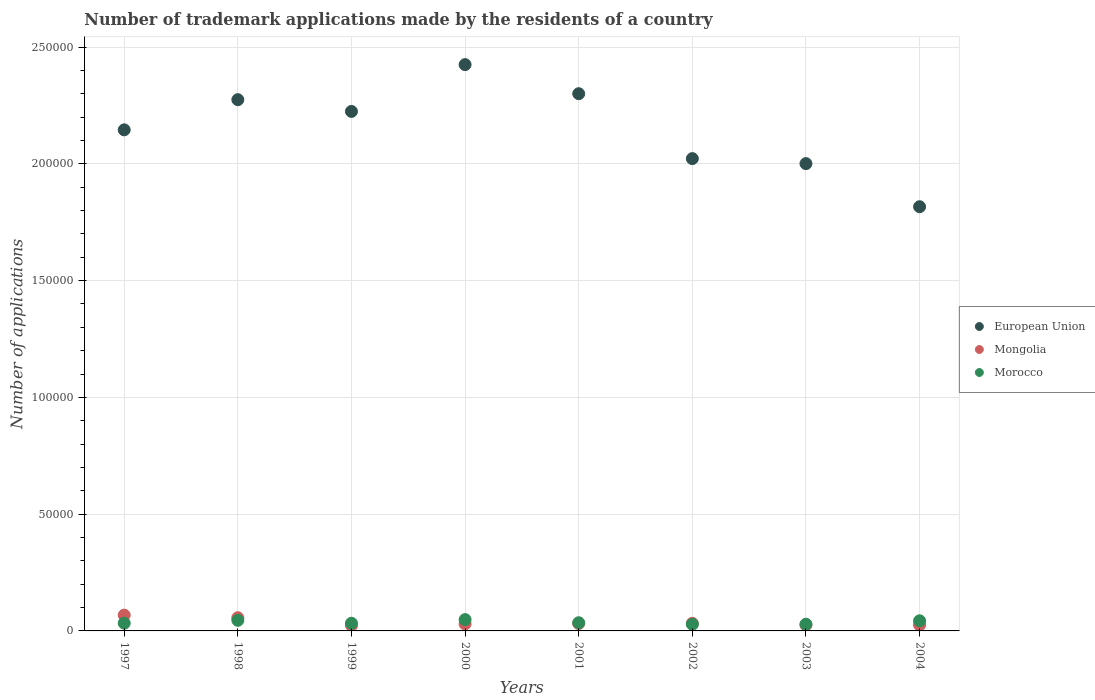How many different coloured dotlines are there?
Provide a short and direct response. 3. Is the number of dotlines equal to the number of legend labels?
Your response must be concise. Yes. What is the number of trademark applications made by the residents in Morocco in 2001?
Make the answer very short. 3499. Across all years, what is the maximum number of trademark applications made by the residents in Mongolia?
Offer a very short reply. 6760. Across all years, what is the minimum number of trademark applications made by the residents in Mongolia?
Your answer should be very brief. 2375. In which year was the number of trademark applications made by the residents in European Union maximum?
Your response must be concise. 2000. What is the total number of trademark applications made by the residents in European Union in the graph?
Make the answer very short. 1.72e+06. What is the difference between the number of trademark applications made by the residents in Morocco in 1998 and that in 2002?
Offer a terse response. 1691. What is the difference between the number of trademark applications made by the residents in Morocco in 1998 and the number of trademark applications made by the residents in Mongolia in 2003?
Provide a short and direct response. 2007. What is the average number of trademark applications made by the residents in Morocco per year?
Ensure brevity in your answer.  3691.5. In the year 1999, what is the difference between the number of trademark applications made by the residents in European Union and number of trademark applications made by the residents in Morocco?
Give a very brief answer. 2.19e+05. In how many years, is the number of trademark applications made by the residents in Mongolia greater than 200000?
Keep it short and to the point. 0. What is the ratio of the number of trademark applications made by the residents in Morocco in 2002 to that in 2003?
Your response must be concise. 0.99. Is the difference between the number of trademark applications made by the residents in European Union in 1998 and 2002 greater than the difference between the number of trademark applications made by the residents in Morocco in 1998 and 2002?
Provide a succinct answer. Yes. What is the difference between the highest and the second highest number of trademark applications made by the residents in European Union?
Provide a short and direct response. 1.25e+04. What is the difference between the highest and the lowest number of trademark applications made by the residents in Morocco?
Provide a short and direct response. 1990. In how many years, is the number of trademark applications made by the residents in European Union greater than the average number of trademark applications made by the residents in European Union taken over all years?
Provide a succinct answer. 4. Is the sum of the number of trademark applications made by the residents in Mongolia in 2000 and 2004 greater than the maximum number of trademark applications made by the residents in Morocco across all years?
Your response must be concise. Yes. Is the number of trademark applications made by the residents in Morocco strictly greater than the number of trademark applications made by the residents in European Union over the years?
Give a very brief answer. No. How many dotlines are there?
Give a very brief answer. 3. How many years are there in the graph?
Provide a succinct answer. 8. What is the difference between two consecutive major ticks on the Y-axis?
Your answer should be very brief. 5.00e+04. Does the graph contain grids?
Your answer should be compact. Yes. How are the legend labels stacked?
Your response must be concise. Vertical. What is the title of the graph?
Provide a short and direct response. Number of trademark applications made by the residents of a country. What is the label or title of the X-axis?
Provide a succinct answer. Years. What is the label or title of the Y-axis?
Your answer should be very brief. Number of applications. What is the Number of applications of European Union in 1997?
Make the answer very short. 2.15e+05. What is the Number of applications of Mongolia in 1997?
Provide a short and direct response. 6760. What is the Number of applications of Morocco in 1997?
Offer a terse response. 3312. What is the Number of applications of European Union in 1998?
Your answer should be very brief. 2.27e+05. What is the Number of applications of Mongolia in 1998?
Give a very brief answer. 5648. What is the Number of applications of Morocco in 1998?
Provide a succinct answer. 4540. What is the Number of applications in European Union in 1999?
Your answer should be compact. 2.22e+05. What is the Number of applications in Mongolia in 1999?
Offer a very short reply. 2375. What is the Number of applications in Morocco in 1999?
Your answer should be compact. 3283. What is the Number of applications in European Union in 2000?
Your answer should be very brief. 2.42e+05. What is the Number of applications of Mongolia in 2000?
Ensure brevity in your answer.  2970. What is the Number of applications of Morocco in 2000?
Provide a short and direct response. 4839. What is the Number of applications in European Union in 2001?
Your answer should be very brief. 2.30e+05. What is the Number of applications of Mongolia in 2001?
Offer a very short reply. 3189. What is the Number of applications of Morocco in 2001?
Your answer should be compact. 3499. What is the Number of applications in European Union in 2002?
Provide a short and direct response. 2.02e+05. What is the Number of applications of Mongolia in 2002?
Make the answer very short. 3260. What is the Number of applications of Morocco in 2002?
Give a very brief answer. 2849. What is the Number of applications in European Union in 2003?
Make the answer very short. 2.00e+05. What is the Number of applications of Mongolia in 2003?
Make the answer very short. 2533. What is the Number of applications in Morocco in 2003?
Give a very brief answer. 2875. What is the Number of applications of European Union in 2004?
Your response must be concise. 1.82e+05. What is the Number of applications of Mongolia in 2004?
Provide a succinct answer. 2559. What is the Number of applications in Morocco in 2004?
Offer a very short reply. 4335. Across all years, what is the maximum Number of applications of European Union?
Your response must be concise. 2.42e+05. Across all years, what is the maximum Number of applications of Mongolia?
Your answer should be compact. 6760. Across all years, what is the maximum Number of applications of Morocco?
Your response must be concise. 4839. Across all years, what is the minimum Number of applications in European Union?
Ensure brevity in your answer.  1.82e+05. Across all years, what is the minimum Number of applications in Mongolia?
Ensure brevity in your answer.  2375. Across all years, what is the minimum Number of applications in Morocco?
Your response must be concise. 2849. What is the total Number of applications of European Union in the graph?
Your answer should be compact. 1.72e+06. What is the total Number of applications in Mongolia in the graph?
Give a very brief answer. 2.93e+04. What is the total Number of applications in Morocco in the graph?
Offer a terse response. 2.95e+04. What is the difference between the Number of applications of European Union in 1997 and that in 1998?
Your response must be concise. -1.29e+04. What is the difference between the Number of applications in Mongolia in 1997 and that in 1998?
Give a very brief answer. 1112. What is the difference between the Number of applications in Morocco in 1997 and that in 1998?
Your answer should be very brief. -1228. What is the difference between the Number of applications of European Union in 1997 and that in 1999?
Provide a short and direct response. -7887. What is the difference between the Number of applications in Mongolia in 1997 and that in 1999?
Your response must be concise. 4385. What is the difference between the Number of applications in Morocco in 1997 and that in 1999?
Your response must be concise. 29. What is the difference between the Number of applications of European Union in 1997 and that in 2000?
Give a very brief answer. -2.79e+04. What is the difference between the Number of applications in Mongolia in 1997 and that in 2000?
Keep it short and to the point. 3790. What is the difference between the Number of applications in Morocco in 1997 and that in 2000?
Keep it short and to the point. -1527. What is the difference between the Number of applications in European Union in 1997 and that in 2001?
Your response must be concise. -1.55e+04. What is the difference between the Number of applications of Mongolia in 1997 and that in 2001?
Keep it short and to the point. 3571. What is the difference between the Number of applications of Morocco in 1997 and that in 2001?
Provide a succinct answer. -187. What is the difference between the Number of applications of European Union in 1997 and that in 2002?
Your answer should be very brief. 1.23e+04. What is the difference between the Number of applications of Mongolia in 1997 and that in 2002?
Offer a terse response. 3500. What is the difference between the Number of applications of Morocco in 1997 and that in 2002?
Your answer should be compact. 463. What is the difference between the Number of applications in European Union in 1997 and that in 2003?
Your response must be concise. 1.45e+04. What is the difference between the Number of applications of Mongolia in 1997 and that in 2003?
Your answer should be very brief. 4227. What is the difference between the Number of applications in Morocco in 1997 and that in 2003?
Offer a terse response. 437. What is the difference between the Number of applications in European Union in 1997 and that in 2004?
Your response must be concise. 3.29e+04. What is the difference between the Number of applications of Mongolia in 1997 and that in 2004?
Your response must be concise. 4201. What is the difference between the Number of applications in Morocco in 1997 and that in 2004?
Provide a succinct answer. -1023. What is the difference between the Number of applications in European Union in 1998 and that in 1999?
Make the answer very short. 5029. What is the difference between the Number of applications in Mongolia in 1998 and that in 1999?
Provide a short and direct response. 3273. What is the difference between the Number of applications in Morocco in 1998 and that in 1999?
Your answer should be very brief. 1257. What is the difference between the Number of applications of European Union in 1998 and that in 2000?
Make the answer very short. -1.50e+04. What is the difference between the Number of applications of Mongolia in 1998 and that in 2000?
Provide a short and direct response. 2678. What is the difference between the Number of applications in Morocco in 1998 and that in 2000?
Ensure brevity in your answer.  -299. What is the difference between the Number of applications of European Union in 1998 and that in 2001?
Keep it short and to the point. -2562. What is the difference between the Number of applications in Mongolia in 1998 and that in 2001?
Make the answer very short. 2459. What is the difference between the Number of applications of Morocco in 1998 and that in 2001?
Offer a terse response. 1041. What is the difference between the Number of applications in European Union in 1998 and that in 2002?
Your answer should be very brief. 2.52e+04. What is the difference between the Number of applications of Mongolia in 1998 and that in 2002?
Offer a terse response. 2388. What is the difference between the Number of applications of Morocco in 1998 and that in 2002?
Your answer should be compact. 1691. What is the difference between the Number of applications in European Union in 1998 and that in 2003?
Give a very brief answer. 2.74e+04. What is the difference between the Number of applications in Mongolia in 1998 and that in 2003?
Provide a short and direct response. 3115. What is the difference between the Number of applications in Morocco in 1998 and that in 2003?
Your answer should be very brief. 1665. What is the difference between the Number of applications of European Union in 1998 and that in 2004?
Your response must be concise. 4.58e+04. What is the difference between the Number of applications of Mongolia in 1998 and that in 2004?
Your response must be concise. 3089. What is the difference between the Number of applications of Morocco in 1998 and that in 2004?
Offer a terse response. 205. What is the difference between the Number of applications in European Union in 1999 and that in 2000?
Keep it short and to the point. -2.00e+04. What is the difference between the Number of applications in Mongolia in 1999 and that in 2000?
Your answer should be very brief. -595. What is the difference between the Number of applications in Morocco in 1999 and that in 2000?
Offer a terse response. -1556. What is the difference between the Number of applications in European Union in 1999 and that in 2001?
Your answer should be very brief. -7591. What is the difference between the Number of applications in Mongolia in 1999 and that in 2001?
Give a very brief answer. -814. What is the difference between the Number of applications of Morocco in 1999 and that in 2001?
Keep it short and to the point. -216. What is the difference between the Number of applications in European Union in 1999 and that in 2002?
Your answer should be compact. 2.02e+04. What is the difference between the Number of applications of Mongolia in 1999 and that in 2002?
Give a very brief answer. -885. What is the difference between the Number of applications in Morocco in 1999 and that in 2002?
Keep it short and to the point. 434. What is the difference between the Number of applications in European Union in 1999 and that in 2003?
Offer a very short reply. 2.24e+04. What is the difference between the Number of applications in Mongolia in 1999 and that in 2003?
Give a very brief answer. -158. What is the difference between the Number of applications of Morocco in 1999 and that in 2003?
Provide a succinct answer. 408. What is the difference between the Number of applications in European Union in 1999 and that in 2004?
Keep it short and to the point. 4.08e+04. What is the difference between the Number of applications of Mongolia in 1999 and that in 2004?
Ensure brevity in your answer.  -184. What is the difference between the Number of applications in Morocco in 1999 and that in 2004?
Your response must be concise. -1052. What is the difference between the Number of applications in European Union in 2000 and that in 2001?
Give a very brief answer. 1.25e+04. What is the difference between the Number of applications in Mongolia in 2000 and that in 2001?
Ensure brevity in your answer.  -219. What is the difference between the Number of applications of Morocco in 2000 and that in 2001?
Give a very brief answer. 1340. What is the difference between the Number of applications in European Union in 2000 and that in 2002?
Offer a terse response. 4.03e+04. What is the difference between the Number of applications in Mongolia in 2000 and that in 2002?
Your response must be concise. -290. What is the difference between the Number of applications in Morocco in 2000 and that in 2002?
Keep it short and to the point. 1990. What is the difference between the Number of applications of European Union in 2000 and that in 2003?
Give a very brief answer. 4.24e+04. What is the difference between the Number of applications of Mongolia in 2000 and that in 2003?
Keep it short and to the point. 437. What is the difference between the Number of applications of Morocco in 2000 and that in 2003?
Your answer should be compact. 1964. What is the difference between the Number of applications in European Union in 2000 and that in 2004?
Your answer should be compact. 6.08e+04. What is the difference between the Number of applications in Mongolia in 2000 and that in 2004?
Make the answer very short. 411. What is the difference between the Number of applications in Morocco in 2000 and that in 2004?
Offer a very short reply. 504. What is the difference between the Number of applications of European Union in 2001 and that in 2002?
Provide a short and direct response. 2.78e+04. What is the difference between the Number of applications of Mongolia in 2001 and that in 2002?
Your response must be concise. -71. What is the difference between the Number of applications in Morocco in 2001 and that in 2002?
Give a very brief answer. 650. What is the difference between the Number of applications in European Union in 2001 and that in 2003?
Ensure brevity in your answer.  2.99e+04. What is the difference between the Number of applications in Mongolia in 2001 and that in 2003?
Your answer should be compact. 656. What is the difference between the Number of applications in Morocco in 2001 and that in 2003?
Offer a terse response. 624. What is the difference between the Number of applications of European Union in 2001 and that in 2004?
Give a very brief answer. 4.84e+04. What is the difference between the Number of applications of Mongolia in 2001 and that in 2004?
Your response must be concise. 630. What is the difference between the Number of applications in Morocco in 2001 and that in 2004?
Make the answer very short. -836. What is the difference between the Number of applications of European Union in 2002 and that in 2003?
Offer a very short reply. 2142. What is the difference between the Number of applications of Mongolia in 2002 and that in 2003?
Your response must be concise. 727. What is the difference between the Number of applications of Morocco in 2002 and that in 2003?
Give a very brief answer. -26. What is the difference between the Number of applications of European Union in 2002 and that in 2004?
Ensure brevity in your answer.  2.06e+04. What is the difference between the Number of applications of Mongolia in 2002 and that in 2004?
Give a very brief answer. 701. What is the difference between the Number of applications of Morocco in 2002 and that in 2004?
Provide a short and direct response. -1486. What is the difference between the Number of applications in European Union in 2003 and that in 2004?
Keep it short and to the point. 1.85e+04. What is the difference between the Number of applications of Morocco in 2003 and that in 2004?
Give a very brief answer. -1460. What is the difference between the Number of applications of European Union in 1997 and the Number of applications of Mongolia in 1998?
Keep it short and to the point. 2.09e+05. What is the difference between the Number of applications in European Union in 1997 and the Number of applications in Morocco in 1998?
Offer a very short reply. 2.10e+05. What is the difference between the Number of applications of Mongolia in 1997 and the Number of applications of Morocco in 1998?
Keep it short and to the point. 2220. What is the difference between the Number of applications in European Union in 1997 and the Number of applications in Mongolia in 1999?
Give a very brief answer. 2.12e+05. What is the difference between the Number of applications of European Union in 1997 and the Number of applications of Morocco in 1999?
Provide a succinct answer. 2.11e+05. What is the difference between the Number of applications in Mongolia in 1997 and the Number of applications in Morocco in 1999?
Keep it short and to the point. 3477. What is the difference between the Number of applications of European Union in 1997 and the Number of applications of Mongolia in 2000?
Keep it short and to the point. 2.12e+05. What is the difference between the Number of applications of European Union in 1997 and the Number of applications of Morocco in 2000?
Your response must be concise. 2.10e+05. What is the difference between the Number of applications of Mongolia in 1997 and the Number of applications of Morocco in 2000?
Offer a very short reply. 1921. What is the difference between the Number of applications of European Union in 1997 and the Number of applications of Mongolia in 2001?
Your answer should be very brief. 2.11e+05. What is the difference between the Number of applications in European Union in 1997 and the Number of applications in Morocco in 2001?
Your response must be concise. 2.11e+05. What is the difference between the Number of applications of Mongolia in 1997 and the Number of applications of Morocco in 2001?
Provide a succinct answer. 3261. What is the difference between the Number of applications of European Union in 1997 and the Number of applications of Mongolia in 2002?
Give a very brief answer. 2.11e+05. What is the difference between the Number of applications of European Union in 1997 and the Number of applications of Morocco in 2002?
Make the answer very short. 2.12e+05. What is the difference between the Number of applications of Mongolia in 1997 and the Number of applications of Morocco in 2002?
Your answer should be compact. 3911. What is the difference between the Number of applications of European Union in 1997 and the Number of applications of Mongolia in 2003?
Provide a succinct answer. 2.12e+05. What is the difference between the Number of applications in European Union in 1997 and the Number of applications in Morocco in 2003?
Your answer should be compact. 2.12e+05. What is the difference between the Number of applications in Mongolia in 1997 and the Number of applications in Morocco in 2003?
Provide a short and direct response. 3885. What is the difference between the Number of applications in European Union in 1997 and the Number of applications in Mongolia in 2004?
Offer a very short reply. 2.12e+05. What is the difference between the Number of applications in European Union in 1997 and the Number of applications in Morocco in 2004?
Your response must be concise. 2.10e+05. What is the difference between the Number of applications of Mongolia in 1997 and the Number of applications of Morocco in 2004?
Provide a short and direct response. 2425. What is the difference between the Number of applications of European Union in 1998 and the Number of applications of Mongolia in 1999?
Provide a short and direct response. 2.25e+05. What is the difference between the Number of applications of European Union in 1998 and the Number of applications of Morocco in 1999?
Your answer should be compact. 2.24e+05. What is the difference between the Number of applications of Mongolia in 1998 and the Number of applications of Morocco in 1999?
Provide a succinct answer. 2365. What is the difference between the Number of applications of European Union in 1998 and the Number of applications of Mongolia in 2000?
Give a very brief answer. 2.24e+05. What is the difference between the Number of applications of European Union in 1998 and the Number of applications of Morocco in 2000?
Offer a terse response. 2.23e+05. What is the difference between the Number of applications of Mongolia in 1998 and the Number of applications of Morocco in 2000?
Keep it short and to the point. 809. What is the difference between the Number of applications in European Union in 1998 and the Number of applications in Mongolia in 2001?
Provide a succinct answer. 2.24e+05. What is the difference between the Number of applications in European Union in 1998 and the Number of applications in Morocco in 2001?
Your answer should be very brief. 2.24e+05. What is the difference between the Number of applications in Mongolia in 1998 and the Number of applications in Morocco in 2001?
Offer a terse response. 2149. What is the difference between the Number of applications of European Union in 1998 and the Number of applications of Mongolia in 2002?
Your answer should be very brief. 2.24e+05. What is the difference between the Number of applications in European Union in 1998 and the Number of applications in Morocco in 2002?
Offer a terse response. 2.25e+05. What is the difference between the Number of applications in Mongolia in 1998 and the Number of applications in Morocco in 2002?
Your answer should be compact. 2799. What is the difference between the Number of applications in European Union in 1998 and the Number of applications in Mongolia in 2003?
Your answer should be very brief. 2.25e+05. What is the difference between the Number of applications in European Union in 1998 and the Number of applications in Morocco in 2003?
Offer a terse response. 2.25e+05. What is the difference between the Number of applications of Mongolia in 1998 and the Number of applications of Morocco in 2003?
Your response must be concise. 2773. What is the difference between the Number of applications of European Union in 1998 and the Number of applications of Mongolia in 2004?
Make the answer very short. 2.25e+05. What is the difference between the Number of applications in European Union in 1998 and the Number of applications in Morocco in 2004?
Your answer should be compact. 2.23e+05. What is the difference between the Number of applications in Mongolia in 1998 and the Number of applications in Morocco in 2004?
Offer a very short reply. 1313. What is the difference between the Number of applications in European Union in 1999 and the Number of applications in Mongolia in 2000?
Your answer should be compact. 2.19e+05. What is the difference between the Number of applications of European Union in 1999 and the Number of applications of Morocco in 2000?
Offer a terse response. 2.18e+05. What is the difference between the Number of applications of Mongolia in 1999 and the Number of applications of Morocco in 2000?
Offer a very short reply. -2464. What is the difference between the Number of applications in European Union in 1999 and the Number of applications in Mongolia in 2001?
Offer a very short reply. 2.19e+05. What is the difference between the Number of applications of European Union in 1999 and the Number of applications of Morocco in 2001?
Offer a terse response. 2.19e+05. What is the difference between the Number of applications in Mongolia in 1999 and the Number of applications in Morocco in 2001?
Your answer should be very brief. -1124. What is the difference between the Number of applications of European Union in 1999 and the Number of applications of Mongolia in 2002?
Provide a succinct answer. 2.19e+05. What is the difference between the Number of applications of European Union in 1999 and the Number of applications of Morocco in 2002?
Keep it short and to the point. 2.20e+05. What is the difference between the Number of applications of Mongolia in 1999 and the Number of applications of Morocco in 2002?
Offer a terse response. -474. What is the difference between the Number of applications in European Union in 1999 and the Number of applications in Mongolia in 2003?
Provide a succinct answer. 2.20e+05. What is the difference between the Number of applications of European Union in 1999 and the Number of applications of Morocco in 2003?
Your answer should be very brief. 2.20e+05. What is the difference between the Number of applications of Mongolia in 1999 and the Number of applications of Morocco in 2003?
Your response must be concise. -500. What is the difference between the Number of applications in European Union in 1999 and the Number of applications in Mongolia in 2004?
Provide a short and direct response. 2.20e+05. What is the difference between the Number of applications of European Union in 1999 and the Number of applications of Morocco in 2004?
Offer a terse response. 2.18e+05. What is the difference between the Number of applications of Mongolia in 1999 and the Number of applications of Morocco in 2004?
Give a very brief answer. -1960. What is the difference between the Number of applications of European Union in 2000 and the Number of applications of Mongolia in 2001?
Offer a terse response. 2.39e+05. What is the difference between the Number of applications in European Union in 2000 and the Number of applications in Morocco in 2001?
Keep it short and to the point. 2.39e+05. What is the difference between the Number of applications of Mongolia in 2000 and the Number of applications of Morocco in 2001?
Your answer should be very brief. -529. What is the difference between the Number of applications of European Union in 2000 and the Number of applications of Mongolia in 2002?
Provide a short and direct response. 2.39e+05. What is the difference between the Number of applications of European Union in 2000 and the Number of applications of Morocco in 2002?
Your response must be concise. 2.40e+05. What is the difference between the Number of applications in Mongolia in 2000 and the Number of applications in Morocco in 2002?
Your answer should be compact. 121. What is the difference between the Number of applications of European Union in 2000 and the Number of applications of Mongolia in 2003?
Provide a succinct answer. 2.40e+05. What is the difference between the Number of applications in European Union in 2000 and the Number of applications in Morocco in 2003?
Make the answer very short. 2.40e+05. What is the difference between the Number of applications in Mongolia in 2000 and the Number of applications in Morocco in 2003?
Your response must be concise. 95. What is the difference between the Number of applications of European Union in 2000 and the Number of applications of Mongolia in 2004?
Offer a terse response. 2.40e+05. What is the difference between the Number of applications of European Union in 2000 and the Number of applications of Morocco in 2004?
Offer a terse response. 2.38e+05. What is the difference between the Number of applications in Mongolia in 2000 and the Number of applications in Morocco in 2004?
Your response must be concise. -1365. What is the difference between the Number of applications of European Union in 2001 and the Number of applications of Mongolia in 2002?
Provide a short and direct response. 2.27e+05. What is the difference between the Number of applications of European Union in 2001 and the Number of applications of Morocco in 2002?
Offer a terse response. 2.27e+05. What is the difference between the Number of applications of Mongolia in 2001 and the Number of applications of Morocco in 2002?
Ensure brevity in your answer.  340. What is the difference between the Number of applications in European Union in 2001 and the Number of applications in Mongolia in 2003?
Keep it short and to the point. 2.27e+05. What is the difference between the Number of applications in European Union in 2001 and the Number of applications in Morocco in 2003?
Your answer should be very brief. 2.27e+05. What is the difference between the Number of applications in Mongolia in 2001 and the Number of applications in Morocco in 2003?
Your answer should be compact. 314. What is the difference between the Number of applications in European Union in 2001 and the Number of applications in Mongolia in 2004?
Your response must be concise. 2.27e+05. What is the difference between the Number of applications of European Union in 2001 and the Number of applications of Morocco in 2004?
Offer a terse response. 2.26e+05. What is the difference between the Number of applications in Mongolia in 2001 and the Number of applications in Morocco in 2004?
Offer a terse response. -1146. What is the difference between the Number of applications of European Union in 2002 and the Number of applications of Mongolia in 2003?
Ensure brevity in your answer.  2.00e+05. What is the difference between the Number of applications in European Union in 2002 and the Number of applications in Morocco in 2003?
Provide a short and direct response. 1.99e+05. What is the difference between the Number of applications of Mongolia in 2002 and the Number of applications of Morocco in 2003?
Provide a succinct answer. 385. What is the difference between the Number of applications in European Union in 2002 and the Number of applications in Mongolia in 2004?
Your response must be concise. 2.00e+05. What is the difference between the Number of applications in European Union in 2002 and the Number of applications in Morocco in 2004?
Provide a succinct answer. 1.98e+05. What is the difference between the Number of applications in Mongolia in 2002 and the Number of applications in Morocco in 2004?
Make the answer very short. -1075. What is the difference between the Number of applications in European Union in 2003 and the Number of applications in Mongolia in 2004?
Provide a succinct answer. 1.98e+05. What is the difference between the Number of applications in European Union in 2003 and the Number of applications in Morocco in 2004?
Ensure brevity in your answer.  1.96e+05. What is the difference between the Number of applications in Mongolia in 2003 and the Number of applications in Morocco in 2004?
Give a very brief answer. -1802. What is the average Number of applications in European Union per year?
Ensure brevity in your answer.  2.15e+05. What is the average Number of applications of Mongolia per year?
Your answer should be very brief. 3661.75. What is the average Number of applications in Morocco per year?
Your answer should be compact. 3691.5. In the year 1997, what is the difference between the Number of applications in European Union and Number of applications in Mongolia?
Give a very brief answer. 2.08e+05. In the year 1997, what is the difference between the Number of applications of European Union and Number of applications of Morocco?
Give a very brief answer. 2.11e+05. In the year 1997, what is the difference between the Number of applications in Mongolia and Number of applications in Morocco?
Your response must be concise. 3448. In the year 1998, what is the difference between the Number of applications in European Union and Number of applications in Mongolia?
Keep it short and to the point. 2.22e+05. In the year 1998, what is the difference between the Number of applications of European Union and Number of applications of Morocco?
Your answer should be compact. 2.23e+05. In the year 1998, what is the difference between the Number of applications in Mongolia and Number of applications in Morocco?
Make the answer very short. 1108. In the year 1999, what is the difference between the Number of applications of European Union and Number of applications of Mongolia?
Keep it short and to the point. 2.20e+05. In the year 1999, what is the difference between the Number of applications in European Union and Number of applications in Morocco?
Provide a succinct answer. 2.19e+05. In the year 1999, what is the difference between the Number of applications in Mongolia and Number of applications in Morocco?
Your answer should be very brief. -908. In the year 2000, what is the difference between the Number of applications in European Union and Number of applications in Mongolia?
Your response must be concise. 2.40e+05. In the year 2000, what is the difference between the Number of applications of European Union and Number of applications of Morocco?
Your answer should be compact. 2.38e+05. In the year 2000, what is the difference between the Number of applications in Mongolia and Number of applications in Morocco?
Offer a terse response. -1869. In the year 2001, what is the difference between the Number of applications in European Union and Number of applications in Mongolia?
Your answer should be compact. 2.27e+05. In the year 2001, what is the difference between the Number of applications of European Union and Number of applications of Morocco?
Give a very brief answer. 2.27e+05. In the year 2001, what is the difference between the Number of applications of Mongolia and Number of applications of Morocco?
Your answer should be very brief. -310. In the year 2002, what is the difference between the Number of applications in European Union and Number of applications in Mongolia?
Provide a short and direct response. 1.99e+05. In the year 2002, what is the difference between the Number of applications in European Union and Number of applications in Morocco?
Your answer should be very brief. 1.99e+05. In the year 2002, what is the difference between the Number of applications in Mongolia and Number of applications in Morocco?
Provide a short and direct response. 411. In the year 2003, what is the difference between the Number of applications in European Union and Number of applications in Mongolia?
Make the answer very short. 1.98e+05. In the year 2003, what is the difference between the Number of applications in European Union and Number of applications in Morocco?
Keep it short and to the point. 1.97e+05. In the year 2003, what is the difference between the Number of applications in Mongolia and Number of applications in Morocco?
Your response must be concise. -342. In the year 2004, what is the difference between the Number of applications in European Union and Number of applications in Mongolia?
Your answer should be very brief. 1.79e+05. In the year 2004, what is the difference between the Number of applications in European Union and Number of applications in Morocco?
Give a very brief answer. 1.77e+05. In the year 2004, what is the difference between the Number of applications of Mongolia and Number of applications of Morocco?
Provide a succinct answer. -1776. What is the ratio of the Number of applications of European Union in 1997 to that in 1998?
Provide a short and direct response. 0.94. What is the ratio of the Number of applications in Mongolia in 1997 to that in 1998?
Your response must be concise. 1.2. What is the ratio of the Number of applications of Morocco in 1997 to that in 1998?
Give a very brief answer. 0.73. What is the ratio of the Number of applications in European Union in 1997 to that in 1999?
Offer a very short reply. 0.96. What is the ratio of the Number of applications of Mongolia in 1997 to that in 1999?
Provide a succinct answer. 2.85. What is the ratio of the Number of applications of Morocco in 1997 to that in 1999?
Give a very brief answer. 1.01. What is the ratio of the Number of applications of European Union in 1997 to that in 2000?
Offer a terse response. 0.88. What is the ratio of the Number of applications of Mongolia in 1997 to that in 2000?
Make the answer very short. 2.28. What is the ratio of the Number of applications in Morocco in 1997 to that in 2000?
Make the answer very short. 0.68. What is the ratio of the Number of applications in European Union in 1997 to that in 2001?
Provide a succinct answer. 0.93. What is the ratio of the Number of applications of Mongolia in 1997 to that in 2001?
Make the answer very short. 2.12. What is the ratio of the Number of applications in Morocco in 1997 to that in 2001?
Ensure brevity in your answer.  0.95. What is the ratio of the Number of applications in European Union in 1997 to that in 2002?
Keep it short and to the point. 1.06. What is the ratio of the Number of applications of Mongolia in 1997 to that in 2002?
Offer a very short reply. 2.07. What is the ratio of the Number of applications in Morocco in 1997 to that in 2002?
Ensure brevity in your answer.  1.16. What is the ratio of the Number of applications of European Union in 1997 to that in 2003?
Make the answer very short. 1.07. What is the ratio of the Number of applications in Mongolia in 1997 to that in 2003?
Offer a terse response. 2.67. What is the ratio of the Number of applications of Morocco in 1997 to that in 2003?
Make the answer very short. 1.15. What is the ratio of the Number of applications in European Union in 1997 to that in 2004?
Your response must be concise. 1.18. What is the ratio of the Number of applications of Mongolia in 1997 to that in 2004?
Your response must be concise. 2.64. What is the ratio of the Number of applications in Morocco in 1997 to that in 2004?
Provide a succinct answer. 0.76. What is the ratio of the Number of applications of European Union in 1998 to that in 1999?
Your answer should be compact. 1.02. What is the ratio of the Number of applications of Mongolia in 1998 to that in 1999?
Provide a succinct answer. 2.38. What is the ratio of the Number of applications of Morocco in 1998 to that in 1999?
Your answer should be very brief. 1.38. What is the ratio of the Number of applications of European Union in 1998 to that in 2000?
Ensure brevity in your answer.  0.94. What is the ratio of the Number of applications in Mongolia in 1998 to that in 2000?
Ensure brevity in your answer.  1.9. What is the ratio of the Number of applications of Morocco in 1998 to that in 2000?
Provide a short and direct response. 0.94. What is the ratio of the Number of applications in European Union in 1998 to that in 2001?
Your answer should be very brief. 0.99. What is the ratio of the Number of applications of Mongolia in 1998 to that in 2001?
Give a very brief answer. 1.77. What is the ratio of the Number of applications of Morocco in 1998 to that in 2001?
Make the answer very short. 1.3. What is the ratio of the Number of applications in European Union in 1998 to that in 2002?
Your answer should be very brief. 1.12. What is the ratio of the Number of applications of Mongolia in 1998 to that in 2002?
Provide a succinct answer. 1.73. What is the ratio of the Number of applications of Morocco in 1998 to that in 2002?
Ensure brevity in your answer.  1.59. What is the ratio of the Number of applications in European Union in 1998 to that in 2003?
Keep it short and to the point. 1.14. What is the ratio of the Number of applications of Mongolia in 1998 to that in 2003?
Make the answer very short. 2.23. What is the ratio of the Number of applications of Morocco in 1998 to that in 2003?
Your answer should be very brief. 1.58. What is the ratio of the Number of applications of European Union in 1998 to that in 2004?
Ensure brevity in your answer.  1.25. What is the ratio of the Number of applications of Mongolia in 1998 to that in 2004?
Offer a terse response. 2.21. What is the ratio of the Number of applications in Morocco in 1998 to that in 2004?
Provide a short and direct response. 1.05. What is the ratio of the Number of applications in European Union in 1999 to that in 2000?
Your response must be concise. 0.92. What is the ratio of the Number of applications of Mongolia in 1999 to that in 2000?
Ensure brevity in your answer.  0.8. What is the ratio of the Number of applications in Morocco in 1999 to that in 2000?
Offer a very short reply. 0.68. What is the ratio of the Number of applications in Mongolia in 1999 to that in 2001?
Provide a succinct answer. 0.74. What is the ratio of the Number of applications of Morocco in 1999 to that in 2001?
Provide a succinct answer. 0.94. What is the ratio of the Number of applications in European Union in 1999 to that in 2002?
Provide a short and direct response. 1.1. What is the ratio of the Number of applications of Mongolia in 1999 to that in 2002?
Offer a very short reply. 0.73. What is the ratio of the Number of applications of Morocco in 1999 to that in 2002?
Offer a terse response. 1.15. What is the ratio of the Number of applications of European Union in 1999 to that in 2003?
Your response must be concise. 1.11. What is the ratio of the Number of applications of Mongolia in 1999 to that in 2003?
Your answer should be compact. 0.94. What is the ratio of the Number of applications in Morocco in 1999 to that in 2003?
Make the answer very short. 1.14. What is the ratio of the Number of applications in European Union in 1999 to that in 2004?
Offer a terse response. 1.22. What is the ratio of the Number of applications in Mongolia in 1999 to that in 2004?
Offer a very short reply. 0.93. What is the ratio of the Number of applications in Morocco in 1999 to that in 2004?
Keep it short and to the point. 0.76. What is the ratio of the Number of applications of European Union in 2000 to that in 2001?
Your answer should be compact. 1.05. What is the ratio of the Number of applications in Mongolia in 2000 to that in 2001?
Make the answer very short. 0.93. What is the ratio of the Number of applications of Morocco in 2000 to that in 2001?
Keep it short and to the point. 1.38. What is the ratio of the Number of applications of European Union in 2000 to that in 2002?
Offer a terse response. 1.2. What is the ratio of the Number of applications of Mongolia in 2000 to that in 2002?
Offer a very short reply. 0.91. What is the ratio of the Number of applications in Morocco in 2000 to that in 2002?
Provide a short and direct response. 1.7. What is the ratio of the Number of applications of European Union in 2000 to that in 2003?
Your answer should be very brief. 1.21. What is the ratio of the Number of applications in Mongolia in 2000 to that in 2003?
Make the answer very short. 1.17. What is the ratio of the Number of applications in Morocco in 2000 to that in 2003?
Offer a terse response. 1.68. What is the ratio of the Number of applications in European Union in 2000 to that in 2004?
Give a very brief answer. 1.33. What is the ratio of the Number of applications in Mongolia in 2000 to that in 2004?
Give a very brief answer. 1.16. What is the ratio of the Number of applications in Morocco in 2000 to that in 2004?
Your answer should be very brief. 1.12. What is the ratio of the Number of applications in European Union in 2001 to that in 2002?
Provide a short and direct response. 1.14. What is the ratio of the Number of applications of Mongolia in 2001 to that in 2002?
Offer a very short reply. 0.98. What is the ratio of the Number of applications in Morocco in 2001 to that in 2002?
Offer a terse response. 1.23. What is the ratio of the Number of applications in European Union in 2001 to that in 2003?
Offer a very short reply. 1.15. What is the ratio of the Number of applications in Mongolia in 2001 to that in 2003?
Provide a short and direct response. 1.26. What is the ratio of the Number of applications of Morocco in 2001 to that in 2003?
Provide a short and direct response. 1.22. What is the ratio of the Number of applications in European Union in 2001 to that in 2004?
Offer a terse response. 1.27. What is the ratio of the Number of applications in Mongolia in 2001 to that in 2004?
Keep it short and to the point. 1.25. What is the ratio of the Number of applications in Morocco in 2001 to that in 2004?
Your response must be concise. 0.81. What is the ratio of the Number of applications of European Union in 2002 to that in 2003?
Offer a terse response. 1.01. What is the ratio of the Number of applications of Mongolia in 2002 to that in 2003?
Your response must be concise. 1.29. What is the ratio of the Number of applications in Morocco in 2002 to that in 2003?
Your answer should be compact. 0.99. What is the ratio of the Number of applications in European Union in 2002 to that in 2004?
Your response must be concise. 1.11. What is the ratio of the Number of applications of Mongolia in 2002 to that in 2004?
Provide a short and direct response. 1.27. What is the ratio of the Number of applications of Morocco in 2002 to that in 2004?
Your answer should be very brief. 0.66. What is the ratio of the Number of applications in European Union in 2003 to that in 2004?
Offer a very short reply. 1.1. What is the ratio of the Number of applications in Morocco in 2003 to that in 2004?
Offer a terse response. 0.66. What is the difference between the highest and the second highest Number of applications of European Union?
Offer a very short reply. 1.25e+04. What is the difference between the highest and the second highest Number of applications in Mongolia?
Provide a succinct answer. 1112. What is the difference between the highest and the second highest Number of applications of Morocco?
Ensure brevity in your answer.  299. What is the difference between the highest and the lowest Number of applications of European Union?
Provide a succinct answer. 6.08e+04. What is the difference between the highest and the lowest Number of applications in Mongolia?
Your response must be concise. 4385. What is the difference between the highest and the lowest Number of applications in Morocco?
Ensure brevity in your answer.  1990. 